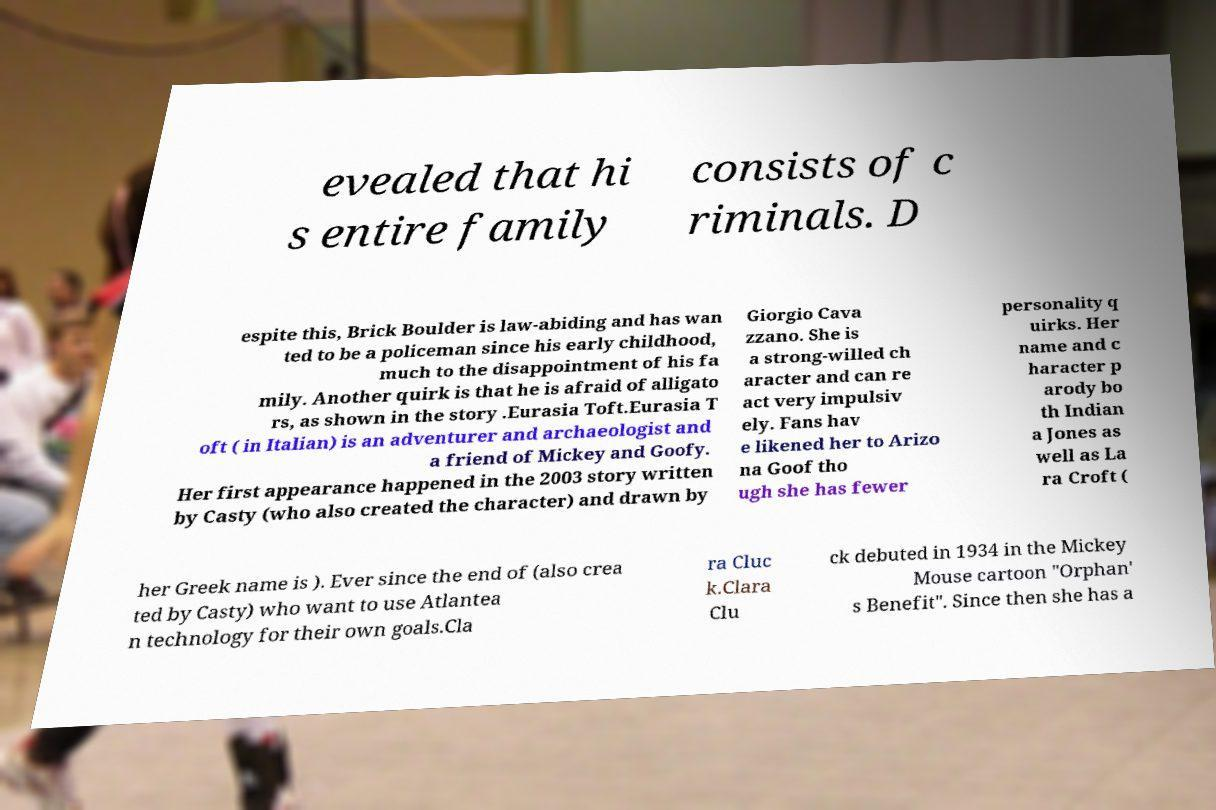Can you accurately transcribe the text from the provided image for me? evealed that hi s entire family consists of c riminals. D espite this, Brick Boulder is law-abiding and has wan ted to be a policeman since his early childhood, much to the disappointment of his fa mily. Another quirk is that he is afraid of alligato rs, as shown in the story .Eurasia Toft.Eurasia T oft ( in Italian) is an adventurer and archaeologist and a friend of Mickey and Goofy. Her first appearance happened in the 2003 story written by Casty (who also created the character) and drawn by Giorgio Cava zzano. She is a strong-willed ch aracter and can re act very impulsiv ely. Fans hav e likened her to Arizo na Goof tho ugh she has fewer personality q uirks. Her name and c haracter p arody bo th Indian a Jones as well as La ra Croft ( her Greek name is ). Ever since the end of (also crea ted by Casty) who want to use Atlantea n technology for their own goals.Cla ra Cluc k.Clara Clu ck debuted in 1934 in the Mickey Mouse cartoon "Orphan' s Benefit". Since then she has a 